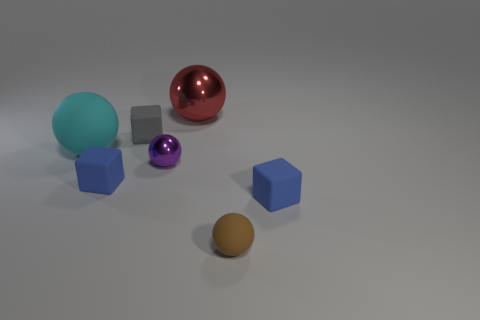Are there an equal number of cyan balls behind the small gray rubber thing and big shiny spheres that are in front of the small brown object?
Offer a very short reply. Yes. What shape is the blue rubber object on the left side of the metallic object on the left side of the large shiny ball?
Keep it short and to the point. Cube. What is the material of the large red thing that is the same shape as the purple object?
Provide a short and direct response. Metal. What color is the other ball that is the same size as the red sphere?
Offer a terse response. Cyan. Are there an equal number of blocks in front of the tiny gray thing and shiny spheres?
Make the answer very short. Yes. There is a sphere in front of the blue block that is right of the gray rubber cube; what is its color?
Your answer should be compact. Brown. There is a rubber block that is to the left of the tiny matte cube that is behind the big cyan rubber thing; what size is it?
Provide a short and direct response. Small. What number of other things are the same size as the red thing?
Ensure brevity in your answer.  1. The large ball to the left of the big object that is right of the rubber sphere left of the red sphere is what color?
Make the answer very short. Cyan. What number of other things are the same shape as the big rubber object?
Give a very brief answer. 3. 